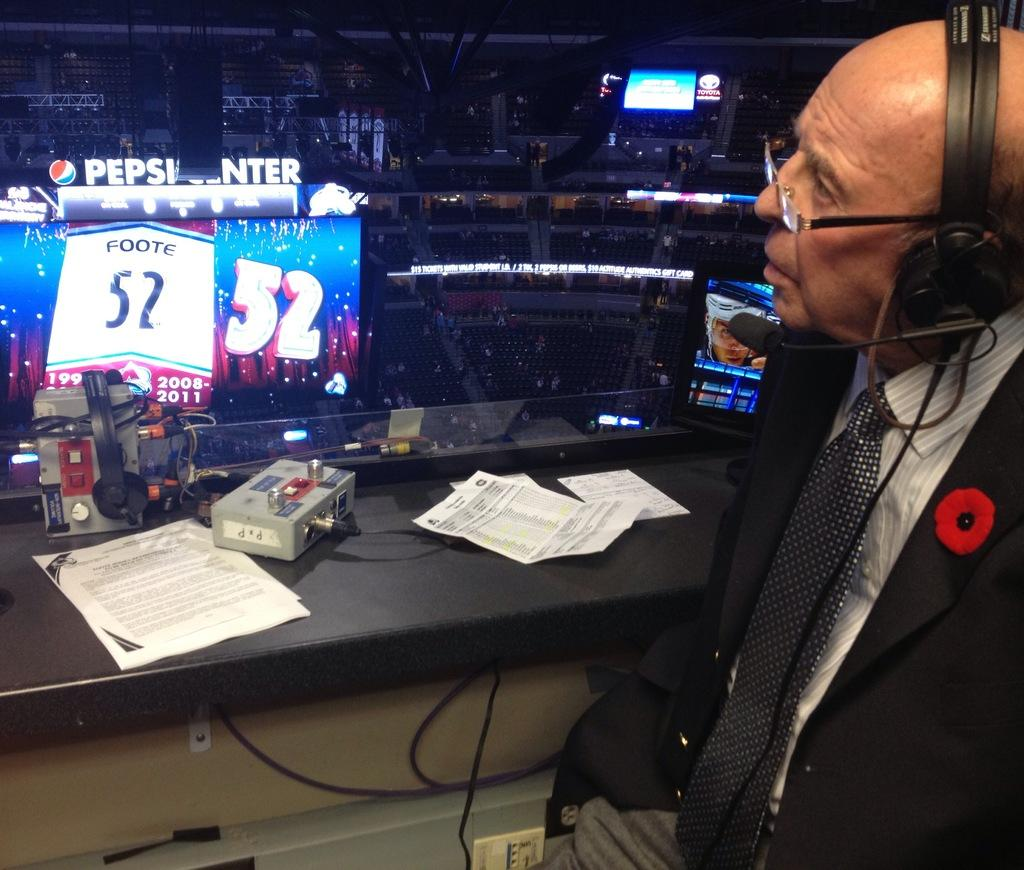<image>
Render a clear and concise summary of the photo. A broadcaster is sitting inside of a suite inside of the Pepsi Center. 